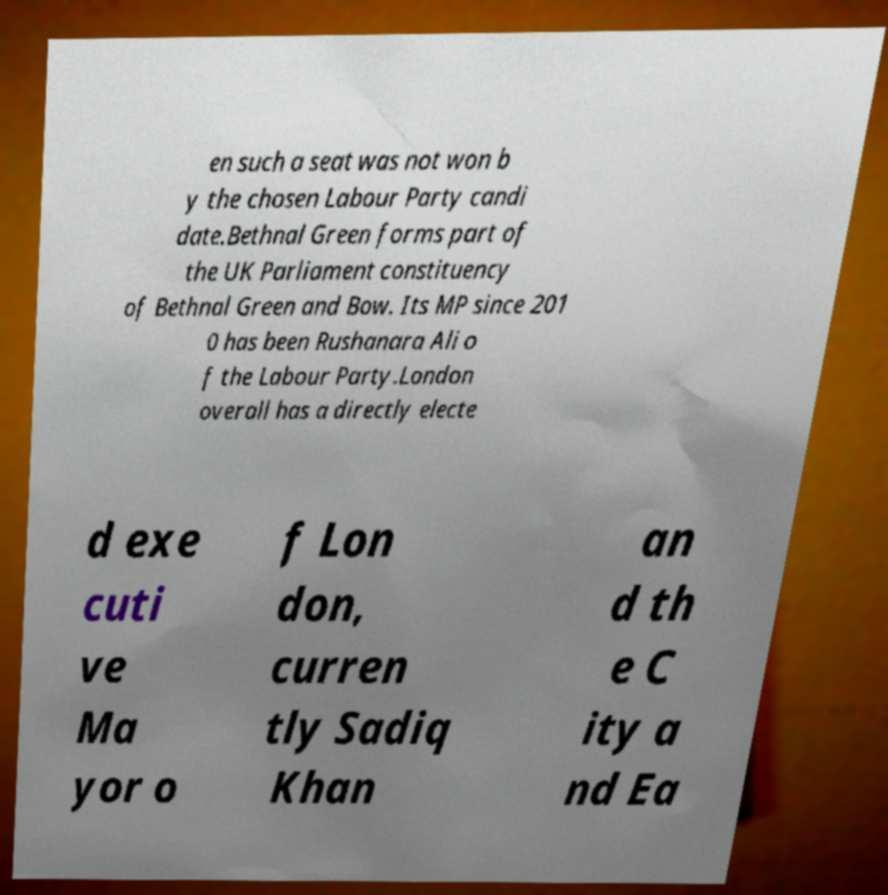There's text embedded in this image that I need extracted. Can you transcribe it verbatim? en such a seat was not won b y the chosen Labour Party candi date.Bethnal Green forms part of the UK Parliament constituency of Bethnal Green and Bow. Its MP since 201 0 has been Rushanara Ali o f the Labour Party.London overall has a directly electe d exe cuti ve Ma yor o f Lon don, curren tly Sadiq Khan an d th e C ity a nd Ea 